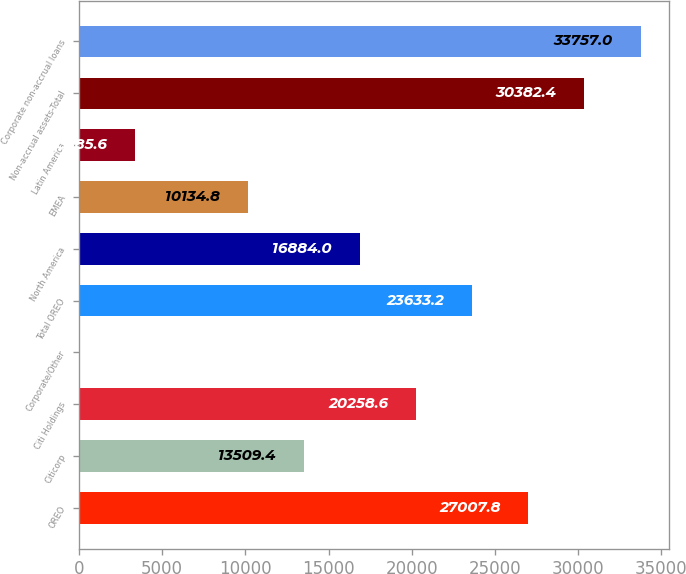Convert chart. <chart><loc_0><loc_0><loc_500><loc_500><bar_chart><fcel>OREO<fcel>Citicorp<fcel>Citi Holdings<fcel>Corporate/Other<fcel>Total OREO<fcel>North America<fcel>EMEA<fcel>Latin America<fcel>Non-accrual assets-Total<fcel>Corporate non-accrual loans<nl><fcel>27007.8<fcel>13509.4<fcel>20258.6<fcel>11<fcel>23633.2<fcel>16884<fcel>10134.8<fcel>3385.6<fcel>30382.4<fcel>33757<nl></chart> 